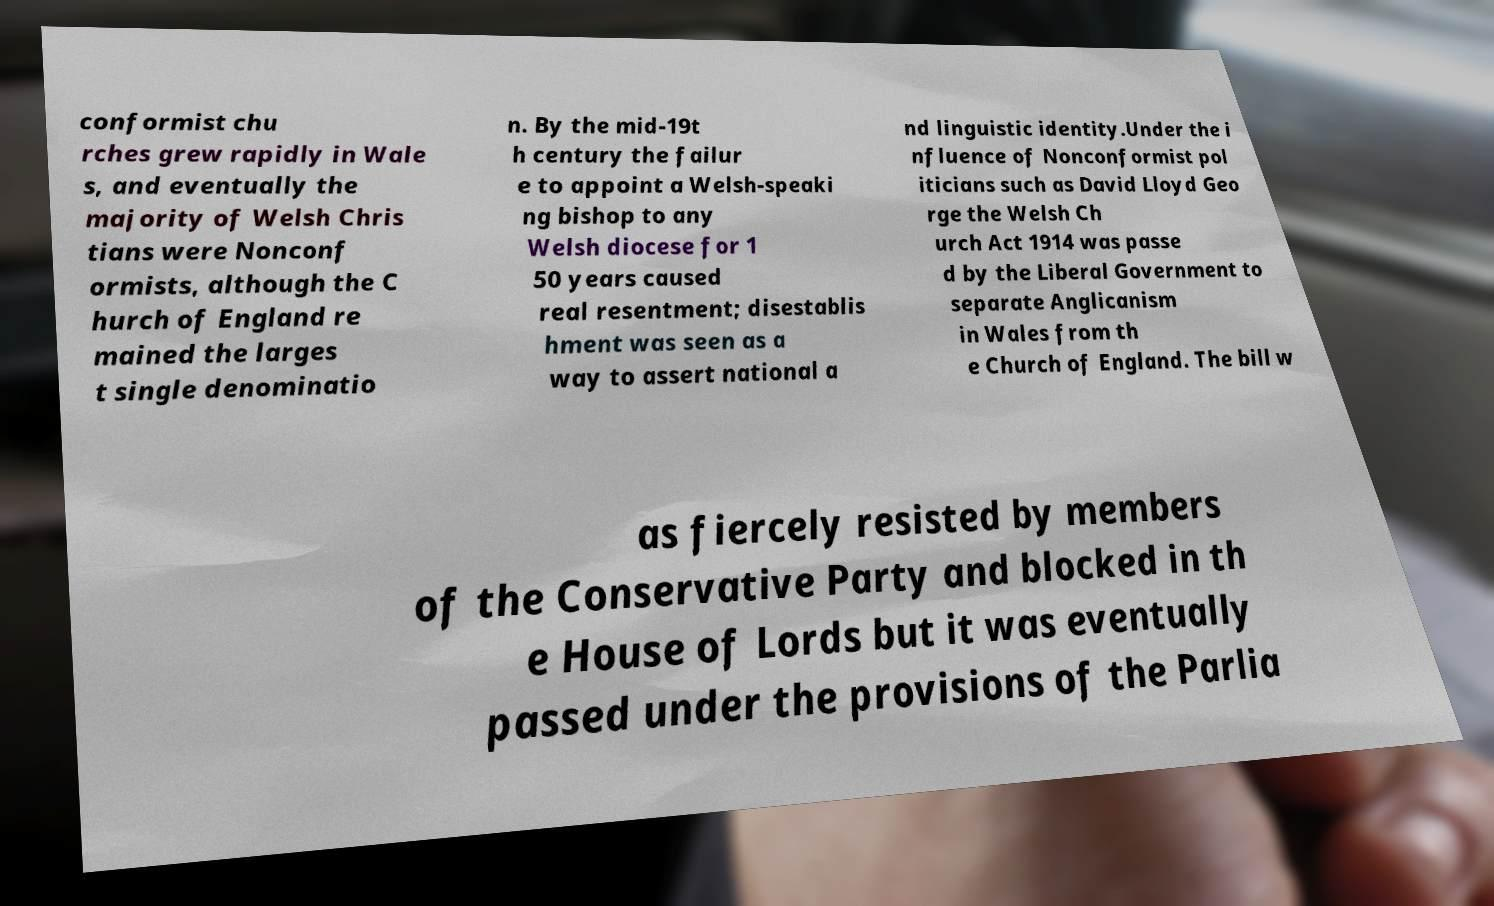Can you read and provide the text displayed in the image?This photo seems to have some interesting text. Can you extract and type it out for me? conformist chu rches grew rapidly in Wale s, and eventually the majority of Welsh Chris tians were Nonconf ormists, although the C hurch of England re mained the larges t single denominatio n. By the mid-19t h century the failur e to appoint a Welsh-speaki ng bishop to any Welsh diocese for 1 50 years caused real resentment; disestablis hment was seen as a way to assert national a nd linguistic identity.Under the i nfluence of Nonconformist pol iticians such as David Lloyd Geo rge the Welsh Ch urch Act 1914 was passe d by the Liberal Government to separate Anglicanism in Wales from th e Church of England. The bill w as fiercely resisted by members of the Conservative Party and blocked in th e House of Lords but it was eventually passed under the provisions of the Parlia 